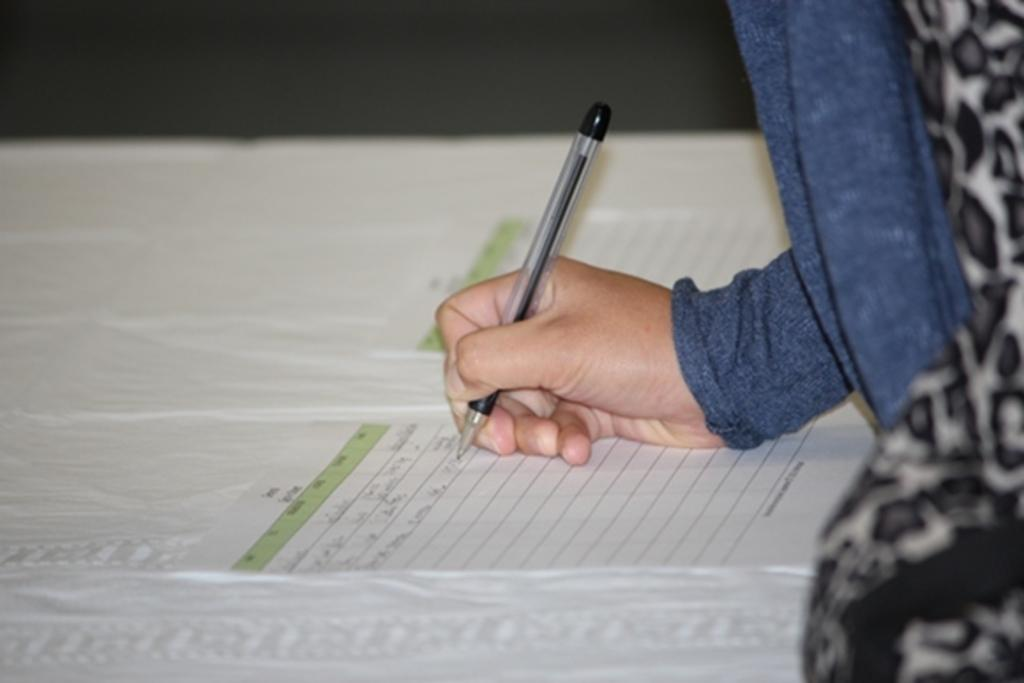What is the person in the image doing? The human in the image is holding a pen and writing on a paper. What else can be seen on the table in the image? There is another paper and a white cloth on the table. What might the person be using to write on the paper? The person is using a pen to write on the paper. Can you see any birds flying over the seashore in the image? There is no seashore or birds present in the image; it features a person writing on a paper with a pen. 